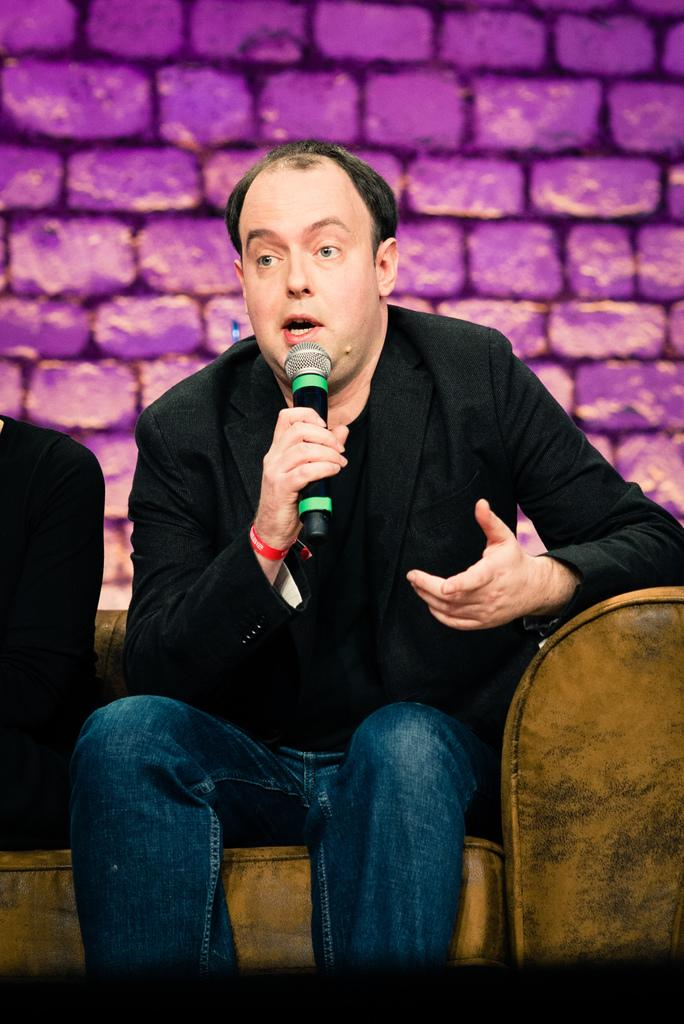Who is the main subject in the image? There is a man in the image. What is the man doing in the image? The man is seated on a chair and speaking. What is the man using to amplify his voice? The man is using a microphone. What type of wound can be seen on the man's arm in the image? There is no wound visible on the man's arm in the image. What type of plants are growing around the man in the image? There are no plants visible in the image. 